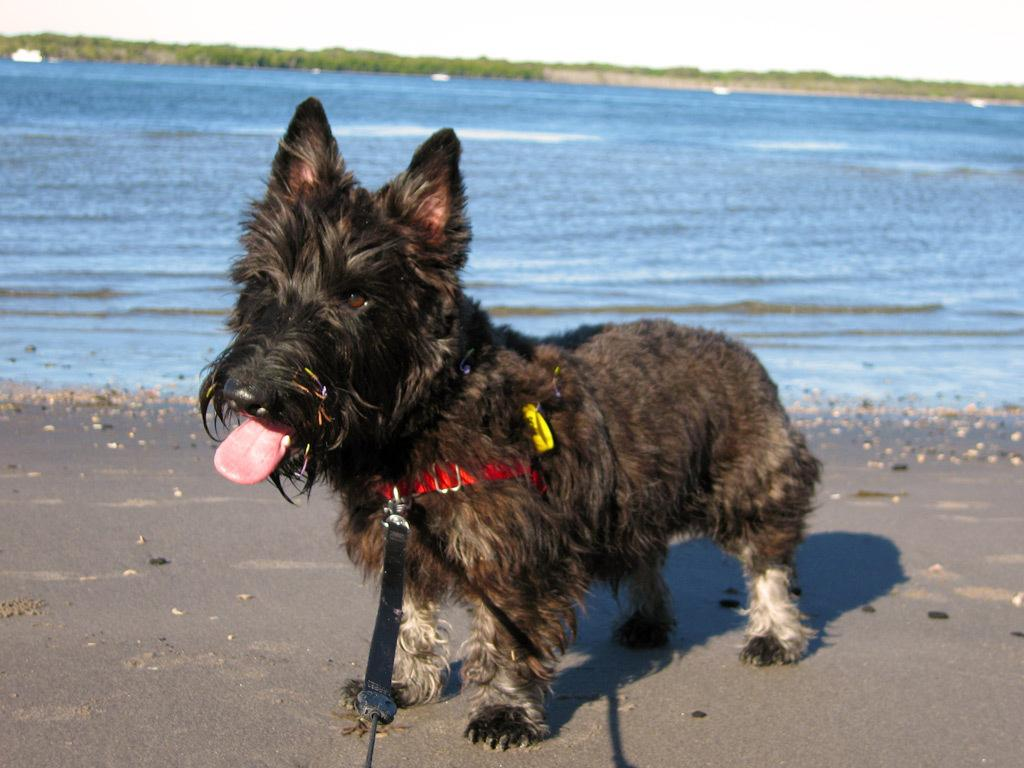What type of animal is in the image? There is a dog in the image. What color is the dog? The dog is brown in color. What can be seen in the background of the image? There is water and trees visible in the background of the image. What color are the trees? The trees are green in color. What is the color of the sky in the image? The sky is white in color. Who is the manager of the park in the image? There is no park or manager present in the image; it features a brown dog with a white sky and green trees in the background. 